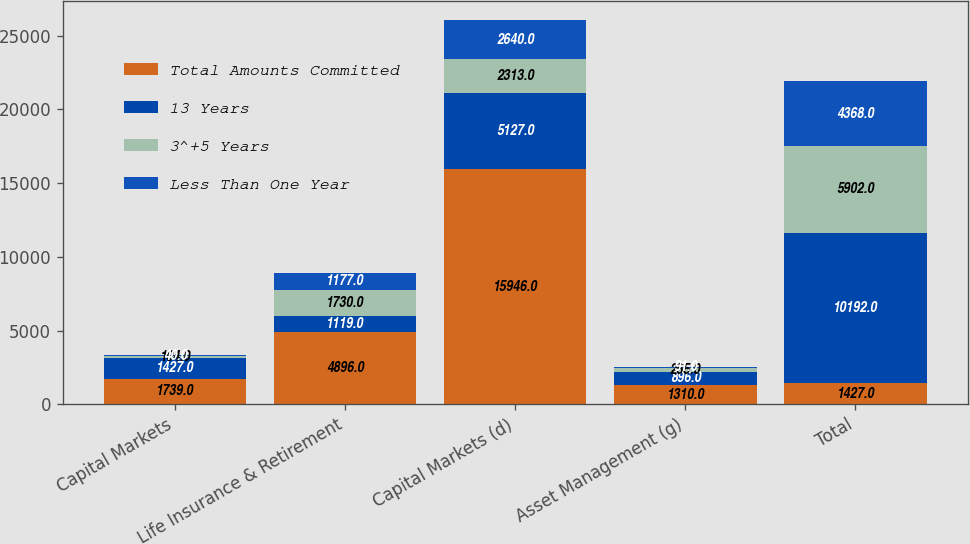Convert chart to OTSL. <chart><loc_0><loc_0><loc_500><loc_500><stacked_bar_chart><ecel><fcel>Capital Markets<fcel>Life Insurance & Retirement<fcel>Capital Markets (d)<fcel>Asset Management (g)<fcel>Total<nl><fcel>Total Amounts Committed<fcel>1739<fcel>4896<fcel>15946<fcel>1310<fcel>1427<nl><fcel>13 Years<fcel>1427<fcel>1119<fcel>5127<fcel>896<fcel>10192<nl><fcel>3^+5 Years<fcel>104<fcel>1730<fcel>2313<fcel>255<fcel>5902<nl><fcel>Less Than One Year<fcel>40<fcel>1177<fcel>2640<fcel>91<fcel>4368<nl></chart> 